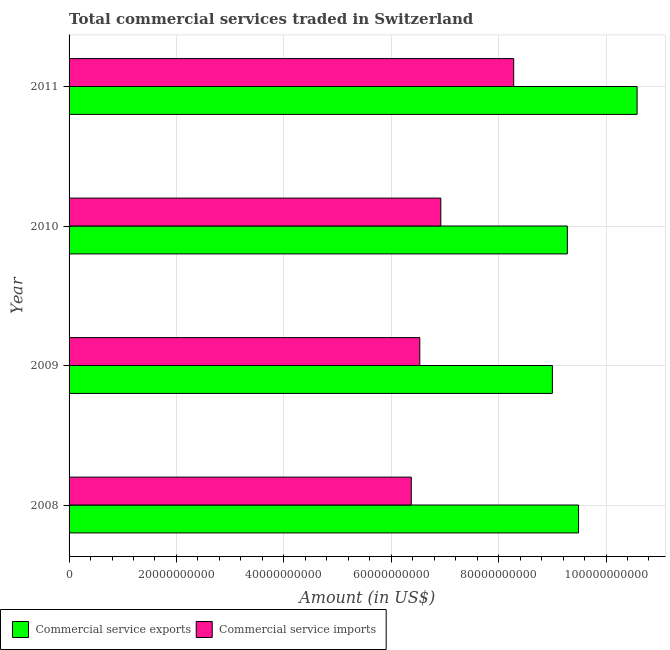How many groups of bars are there?
Make the answer very short. 4. Are the number of bars per tick equal to the number of legend labels?
Ensure brevity in your answer.  Yes. How many bars are there on the 3rd tick from the top?
Provide a short and direct response. 2. How many bars are there on the 1st tick from the bottom?
Make the answer very short. 2. What is the label of the 2nd group of bars from the top?
Offer a terse response. 2010. In how many cases, is the number of bars for a given year not equal to the number of legend labels?
Your response must be concise. 0. What is the amount of commercial service exports in 2011?
Ensure brevity in your answer.  1.06e+11. Across all years, what is the maximum amount of commercial service exports?
Offer a terse response. 1.06e+11. Across all years, what is the minimum amount of commercial service imports?
Your response must be concise. 6.37e+1. What is the total amount of commercial service exports in the graph?
Your response must be concise. 3.83e+11. What is the difference between the amount of commercial service exports in 2008 and that in 2010?
Your answer should be compact. 2.09e+09. What is the difference between the amount of commercial service exports in 2010 and the amount of commercial service imports in 2011?
Provide a short and direct response. 9.99e+09. What is the average amount of commercial service imports per year?
Ensure brevity in your answer.  7.03e+1. In the year 2008, what is the difference between the amount of commercial service imports and amount of commercial service exports?
Give a very brief answer. -3.12e+1. In how many years, is the amount of commercial service exports greater than 92000000000 US$?
Your answer should be compact. 3. What is the ratio of the amount of commercial service imports in 2009 to that in 2011?
Keep it short and to the point. 0.79. Is the amount of commercial service exports in 2010 less than that in 2011?
Provide a succinct answer. Yes. What is the difference between the highest and the second highest amount of commercial service exports?
Keep it short and to the point. 1.09e+1. What is the difference between the highest and the lowest amount of commercial service imports?
Give a very brief answer. 1.91e+1. In how many years, is the amount of commercial service exports greater than the average amount of commercial service exports taken over all years?
Make the answer very short. 1. What does the 2nd bar from the top in 2010 represents?
Offer a terse response. Commercial service exports. What does the 1st bar from the bottom in 2011 represents?
Provide a succinct answer. Commercial service exports. How many bars are there?
Give a very brief answer. 8. Are all the bars in the graph horizontal?
Your answer should be compact. Yes. How many years are there in the graph?
Provide a succinct answer. 4. Are the values on the major ticks of X-axis written in scientific E-notation?
Your answer should be very brief. No. Does the graph contain any zero values?
Make the answer very short. No. How many legend labels are there?
Make the answer very short. 2. How are the legend labels stacked?
Your answer should be very brief. Horizontal. What is the title of the graph?
Ensure brevity in your answer.  Total commercial services traded in Switzerland. Does "Lowest 10% of population" appear as one of the legend labels in the graph?
Your answer should be very brief. No. What is the label or title of the X-axis?
Ensure brevity in your answer.  Amount (in US$). What is the label or title of the Y-axis?
Make the answer very short. Year. What is the Amount (in US$) in Commercial service exports in 2008?
Offer a very short reply. 9.49e+1. What is the Amount (in US$) of Commercial service imports in 2008?
Make the answer very short. 6.37e+1. What is the Amount (in US$) of Commercial service exports in 2009?
Offer a very short reply. 9.00e+1. What is the Amount (in US$) in Commercial service imports in 2009?
Your answer should be very brief. 6.53e+1. What is the Amount (in US$) of Commercial service exports in 2010?
Keep it short and to the point. 9.28e+1. What is the Amount (in US$) in Commercial service imports in 2010?
Your response must be concise. 6.92e+1. What is the Amount (in US$) of Commercial service exports in 2011?
Provide a succinct answer. 1.06e+11. What is the Amount (in US$) in Commercial service imports in 2011?
Ensure brevity in your answer.  8.28e+1. Across all years, what is the maximum Amount (in US$) of Commercial service exports?
Provide a short and direct response. 1.06e+11. Across all years, what is the maximum Amount (in US$) of Commercial service imports?
Your answer should be very brief. 8.28e+1. Across all years, what is the minimum Amount (in US$) in Commercial service exports?
Offer a very short reply. 9.00e+1. Across all years, what is the minimum Amount (in US$) in Commercial service imports?
Your answer should be compact. 6.37e+1. What is the total Amount (in US$) in Commercial service exports in the graph?
Make the answer very short. 3.83e+11. What is the total Amount (in US$) of Commercial service imports in the graph?
Give a very brief answer. 2.81e+11. What is the difference between the Amount (in US$) in Commercial service exports in 2008 and that in 2009?
Your answer should be very brief. 4.87e+09. What is the difference between the Amount (in US$) of Commercial service imports in 2008 and that in 2009?
Your answer should be very brief. -1.58e+09. What is the difference between the Amount (in US$) in Commercial service exports in 2008 and that in 2010?
Make the answer very short. 2.09e+09. What is the difference between the Amount (in US$) of Commercial service imports in 2008 and that in 2010?
Provide a short and direct response. -5.50e+09. What is the difference between the Amount (in US$) in Commercial service exports in 2008 and that in 2011?
Ensure brevity in your answer.  -1.09e+1. What is the difference between the Amount (in US$) of Commercial service imports in 2008 and that in 2011?
Offer a very short reply. -1.91e+1. What is the difference between the Amount (in US$) in Commercial service exports in 2009 and that in 2010?
Keep it short and to the point. -2.78e+09. What is the difference between the Amount (in US$) in Commercial service imports in 2009 and that in 2010?
Offer a terse response. -3.92e+09. What is the difference between the Amount (in US$) of Commercial service exports in 2009 and that in 2011?
Your answer should be compact. -1.58e+1. What is the difference between the Amount (in US$) of Commercial service imports in 2009 and that in 2011?
Make the answer very short. -1.75e+1. What is the difference between the Amount (in US$) in Commercial service exports in 2010 and that in 2011?
Keep it short and to the point. -1.30e+1. What is the difference between the Amount (in US$) of Commercial service imports in 2010 and that in 2011?
Make the answer very short. -1.36e+1. What is the difference between the Amount (in US$) of Commercial service exports in 2008 and the Amount (in US$) of Commercial service imports in 2009?
Provide a short and direct response. 2.96e+1. What is the difference between the Amount (in US$) in Commercial service exports in 2008 and the Amount (in US$) in Commercial service imports in 2010?
Your answer should be very brief. 2.57e+1. What is the difference between the Amount (in US$) in Commercial service exports in 2008 and the Amount (in US$) in Commercial service imports in 2011?
Ensure brevity in your answer.  1.21e+1. What is the difference between the Amount (in US$) of Commercial service exports in 2009 and the Amount (in US$) of Commercial service imports in 2010?
Keep it short and to the point. 2.08e+1. What is the difference between the Amount (in US$) in Commercial service exports in 2009 and the Amount (in US$) in Commercial service imports in 2011?
Ensure brevity in your answer.  7.21e+09. What is the difference between the Amount (in US$) in Commercial service exports in 2010 and the Amount (in US$) in Commercial service imports in 2011?
Provide a succinct answer. 9.99e+09. What is the average Amount (in US$) in Commercial service exports per year?
Ensure brevity in your answer.  9.59e+1. What is the average Amount (in US$) in Commercial service imports per year?
Your answer should be compact. 7.03e+1. In the year 2008, what is the difference between the Amount (in US$) in Commercial service exports and Amount (in US$) in Commercial service imports?
Give a very brief answer. 3.12e+1. In the year 2009, what is the difference between the Amount (in US$) of Commercial service exports and Amount (in US$) of Commercial service imports?
Ensure brevity in your answer.  2.47e+1. In the year 2010, what is the difference between the Amount (in US$) of Commercial service exports and Amount (in US$) of Commercial service imports?
Make the answer very short. 2.36e+1. In the year 2011, what is the difference between the Amount (in US$) in Commercial service exports and Amount (in US$) in Commercial service imports?
Your answer should be very brief. 2.30e+1. What is the ratio of the Amount (in US$) of Commercial service exports in 2008 to that in 2009?
Your answer should be compact. 1.05. What is the ratio of the Amount (in US$) of Commercial service imports in 2008 to that in 2009?
Provide a short and direct response. 0.98. What is the ratio of the Amount (in US$) in Commercial service exports in 2008 to that in 2010?
Offer a terse response. 1.02. What is the ratio of the Amount (in US$) of Commercial service imports in 2008 to that in 2010?
Provide a succinct answer. 0.92. What is the ratio of the Amount (in US$) of Commercial service exports in 2008 to that in 2011?
Make the answer very short. 0.9. What is the ratio of the Amount (in US$) in Commercial service imports in 2008 to that in 2011?
Provide a succinct answer. 0.77. What is the ratio of the Amount (in US$) of Commercial service exports in 2009 to that in 2010?
Your response must be concise. 0.97. What is the ratio of the Amount (in US$) in Commercial service imports in 2009 to that in 2010?
Offer a terse response. 0.94. What is the ratio of the Amount (in US$) in Commercial service exports in 2009 to that in 2011?
Provide a succinct answer. 0.85. What is the ratio of the Amount (in US$) in Commercial service imports in 2009 to that in 2011?
Your answer should be compact. 0.79. What is the ratio of the Amount (in US$) in Commercial service exports in 2010 to that in 2011?
Offer a terse response. 0.88. What is the ratio of the Amount (in US$) in Commercial service imports in 2010 to that in 2011?
Provide a short and direct response. 0.84. What is the difference between the highest and the second highest Amount (in US$) of Commercial service exports?
Provide a succinct answer. 1.09e+1. What is the difference between the highest and the second highest Amount (in US$) in Commercial service imports?
Your response must be concise. 1.36e+1. What is the difference between the highest and the lowest Amount (in US$) in Commercial service exports?
Give a very brief answer. 1.58e+1. What is the difference between the highest and the lowest Amount (in US$) in Commercial service imports?
Offer a very short reply. 1.91e+1. 